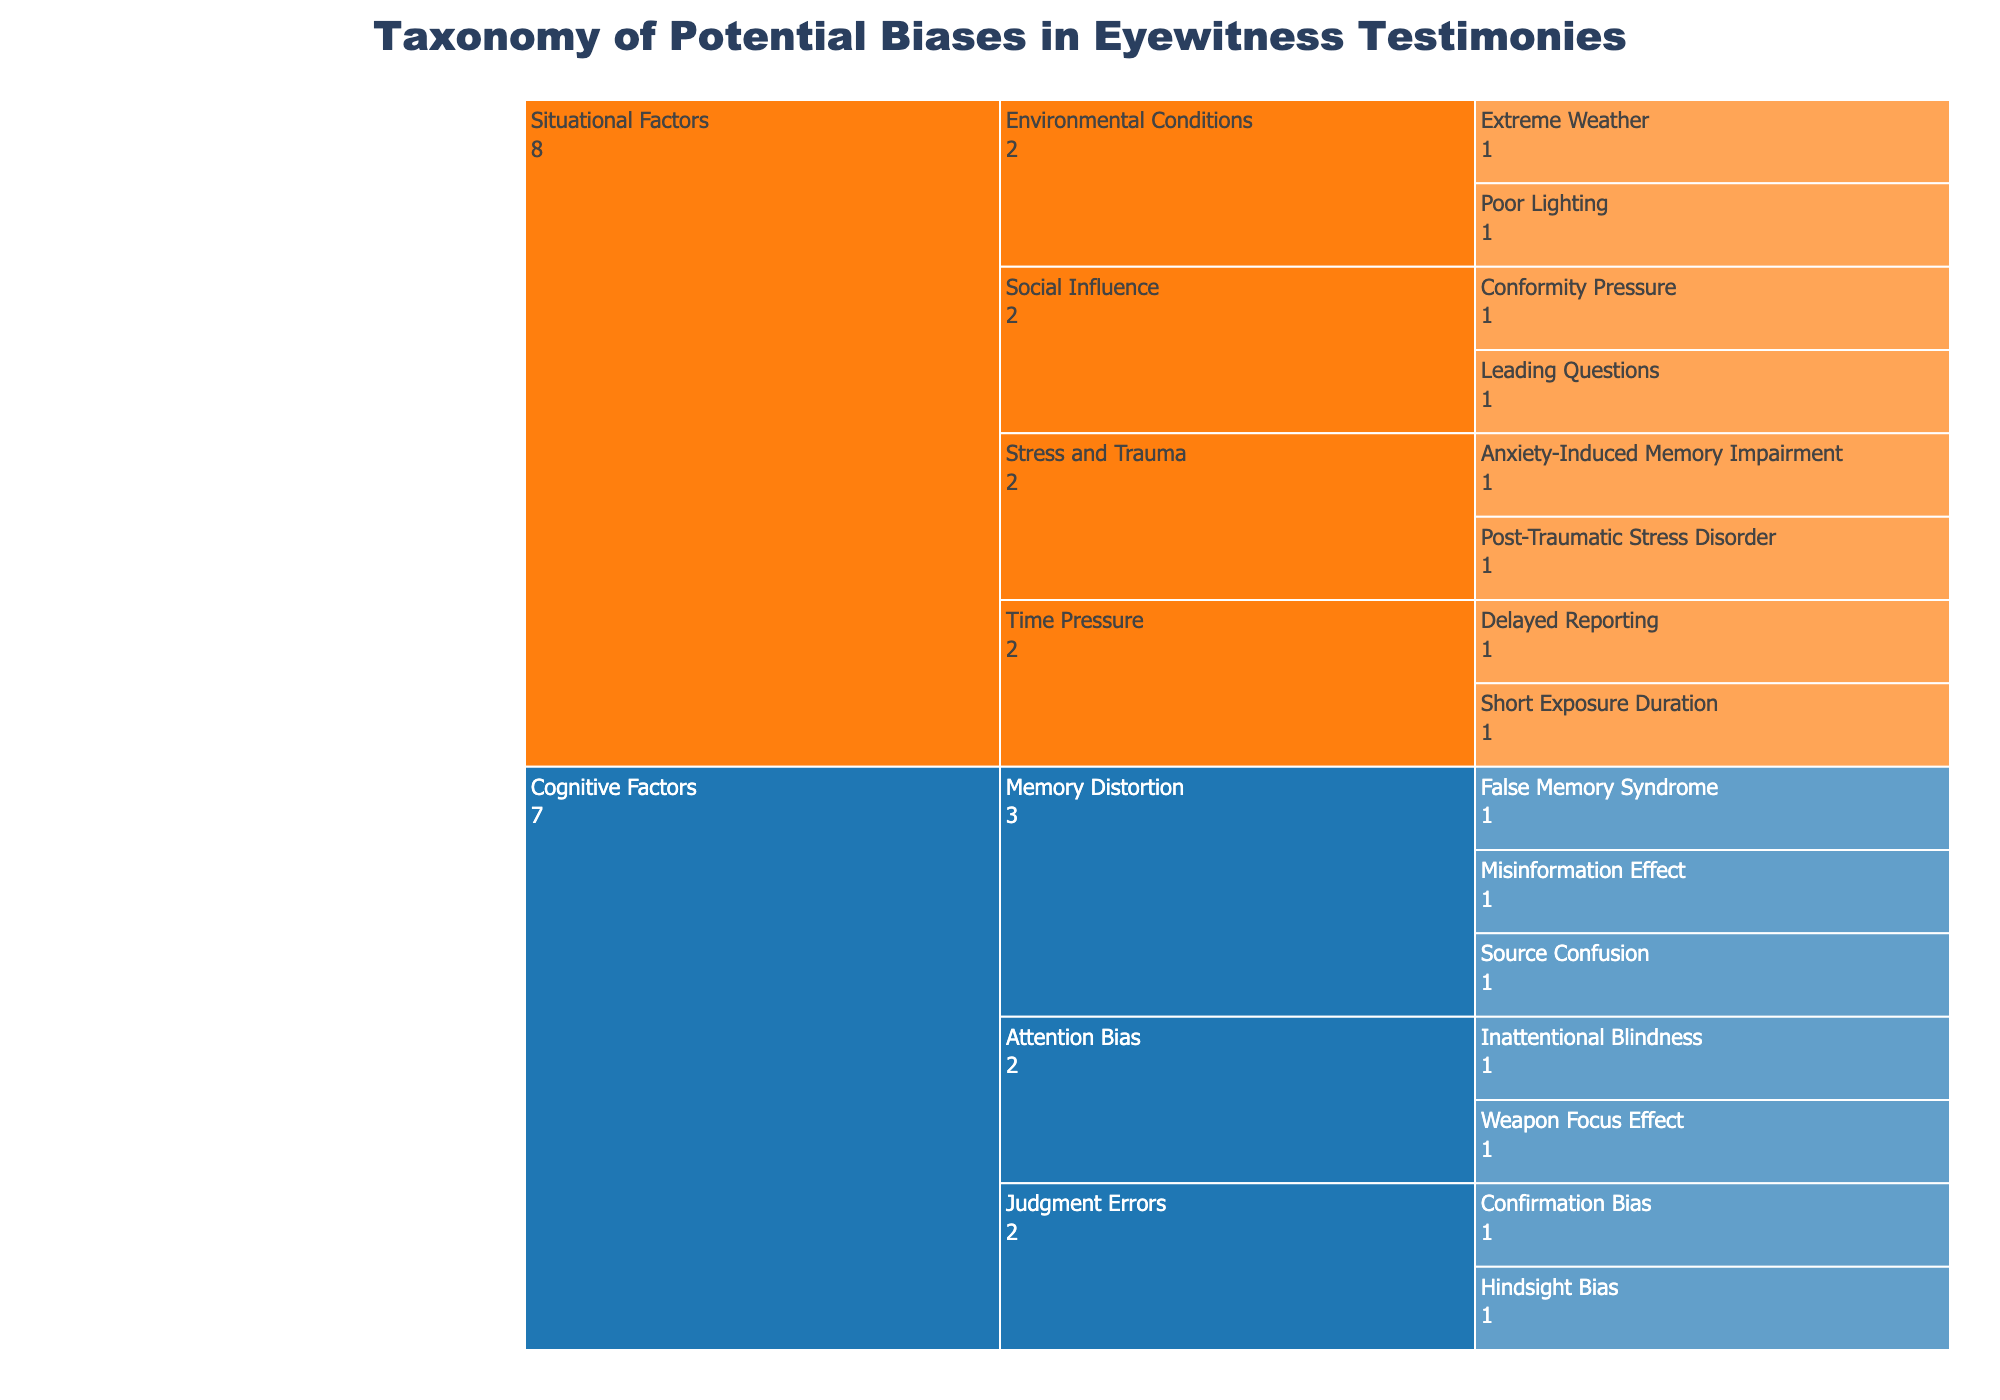what is the title of the figure? The title is displayed at the top center of the figure, written in bold and large font. It reads "Taxonomy of Potential Biases in Eyewitness Testimonies."
Answer: Taxonomy of Potential Biases in Eyewitness Testimonies what color represents cognitive factors? The color scheme for categories is shown in the legend. The Cognitive Factors category is colored in blue.
Answer: Blue how many specific biases are classified under cognitive factors? Under the Cognitive Factors category, there are subcategories Memory Distortion, Attention Bias, and Judgment Errors. Each has multiple specific biases. Counting all specific biases under these subcategories gives us 7 specific biases.
Answer: 7 which specific bias is classified under the situational factor 'Time Pressure'? In the Situational Factors category, under the Time Pressure subcategory, two specific biases are listed: Short Exposure Duration and Delayed Reporting.
Answer: Short Exposure Duration, Delayed Reporting compare the count of specific biases under 'Memory Distortion' with 'Attention Bias'. Which subcategory has more specific biases? Memory Distortion has three specific biases: False Memory Syndrome, Misinformation Effect, and Source Confusion. Attention Bias has two specific biases: Weapon Focus Effect and Inattentional Blindness. Memory Distortion has more specific biases.
Answer: Memory Distortion how many total subcategories are there under the situational factors category? The Situational Factors category includes Environmental Conditions, Time Pressure, Social Influence, and Stress and Trauma — summing up to four subcategories in total.
Answer: 4 which situational factor subcategory has leading questions as a specific bias? Among the subcategories under Situational Factors, Leading Questions is found under Social Influence.
Answer: Social Influence what are the subcategories under the cognitive factors category? The Cognitive Factors category includes Memory Distortion, Attention Bias, and Judgment Errors as its subcategories.
Answer: Memory Distortion, Attention Bias, Judgment Errors what kind of biases are related to confidence errors under cognitive factors? There are no confidence errors explicitly listed under Cognitive Factors. The subcategories listed are related to other types of errors like memory, attention, and judgment.
Answer: None add the specific biases under 'Environmental Conditions' and 'Stress and Trauma'. How many specific biases do you get in total? Under Environmental Conditions, there are Poor Lighting and Extreme Weather, totaling 2. Under Stress and Trauma, there are Post-Traumatic Stress Disorder and Anxiety-Induced Memory Impairment, totaling 2. Adding these together gives 4 specific biases.
Answer: 4 